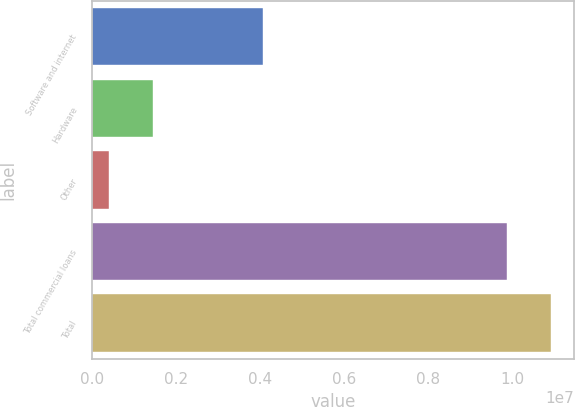<chart> <loc_0><loc_0><loc_500><loc_500><bar_chart><fcel>Software and internet<fcel>Hardware<fcel>Other<fcel>Total commercial loans<fcel>Total<nl><fcel>4.07502e+06<fcel>1.44183e+06<fcel>395954<fcel>9.88269e+06<fcel>1.09286e+07<nl></chart> 